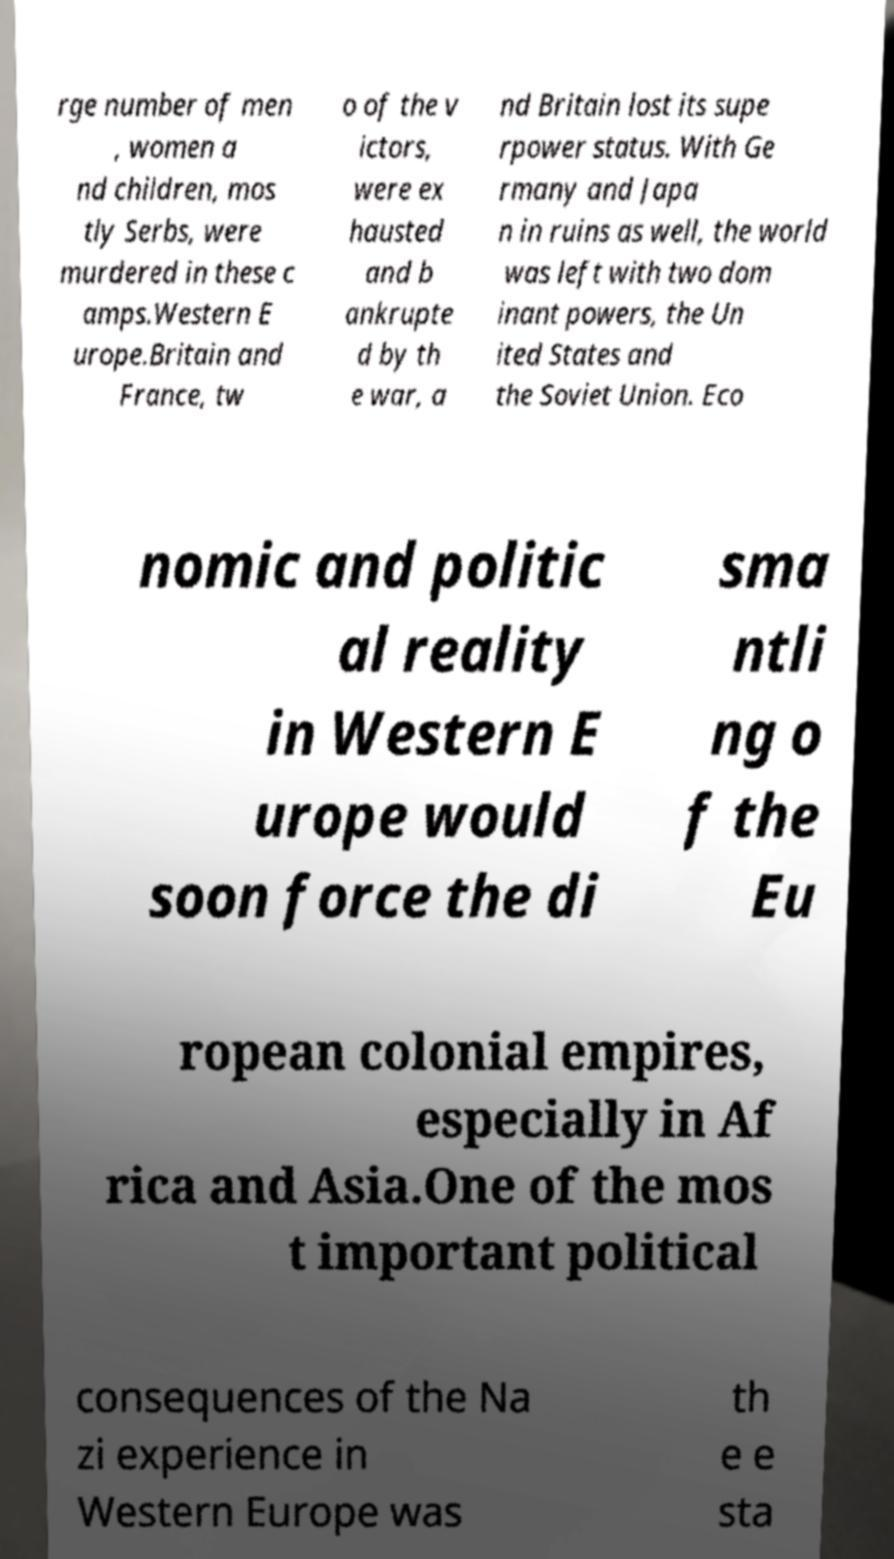There's text embedded in this image that I need extracted. Can you transcribe it verbatim? rge number of men , women a nd children, mos tly Serbs, were murdered in these c amps.Western E urope.Britain and France, tw o of the v ictors, were ex hausted and b ankrupte d by th e war, a nd Britain lost its supe rpower status. With Ge rmany and Japa n in ruins as well, the world was left with two dom inant powers, the Un ited States and the Soviet Union. Eco nomic and politic al reality in Western E urope would soon force the di sma ntli ng o f the Eu ropean colonial empires, especially in Af rica and Asia.One of the mos t important political consequences of the Na zi experience in Western Europe was th e e sta 